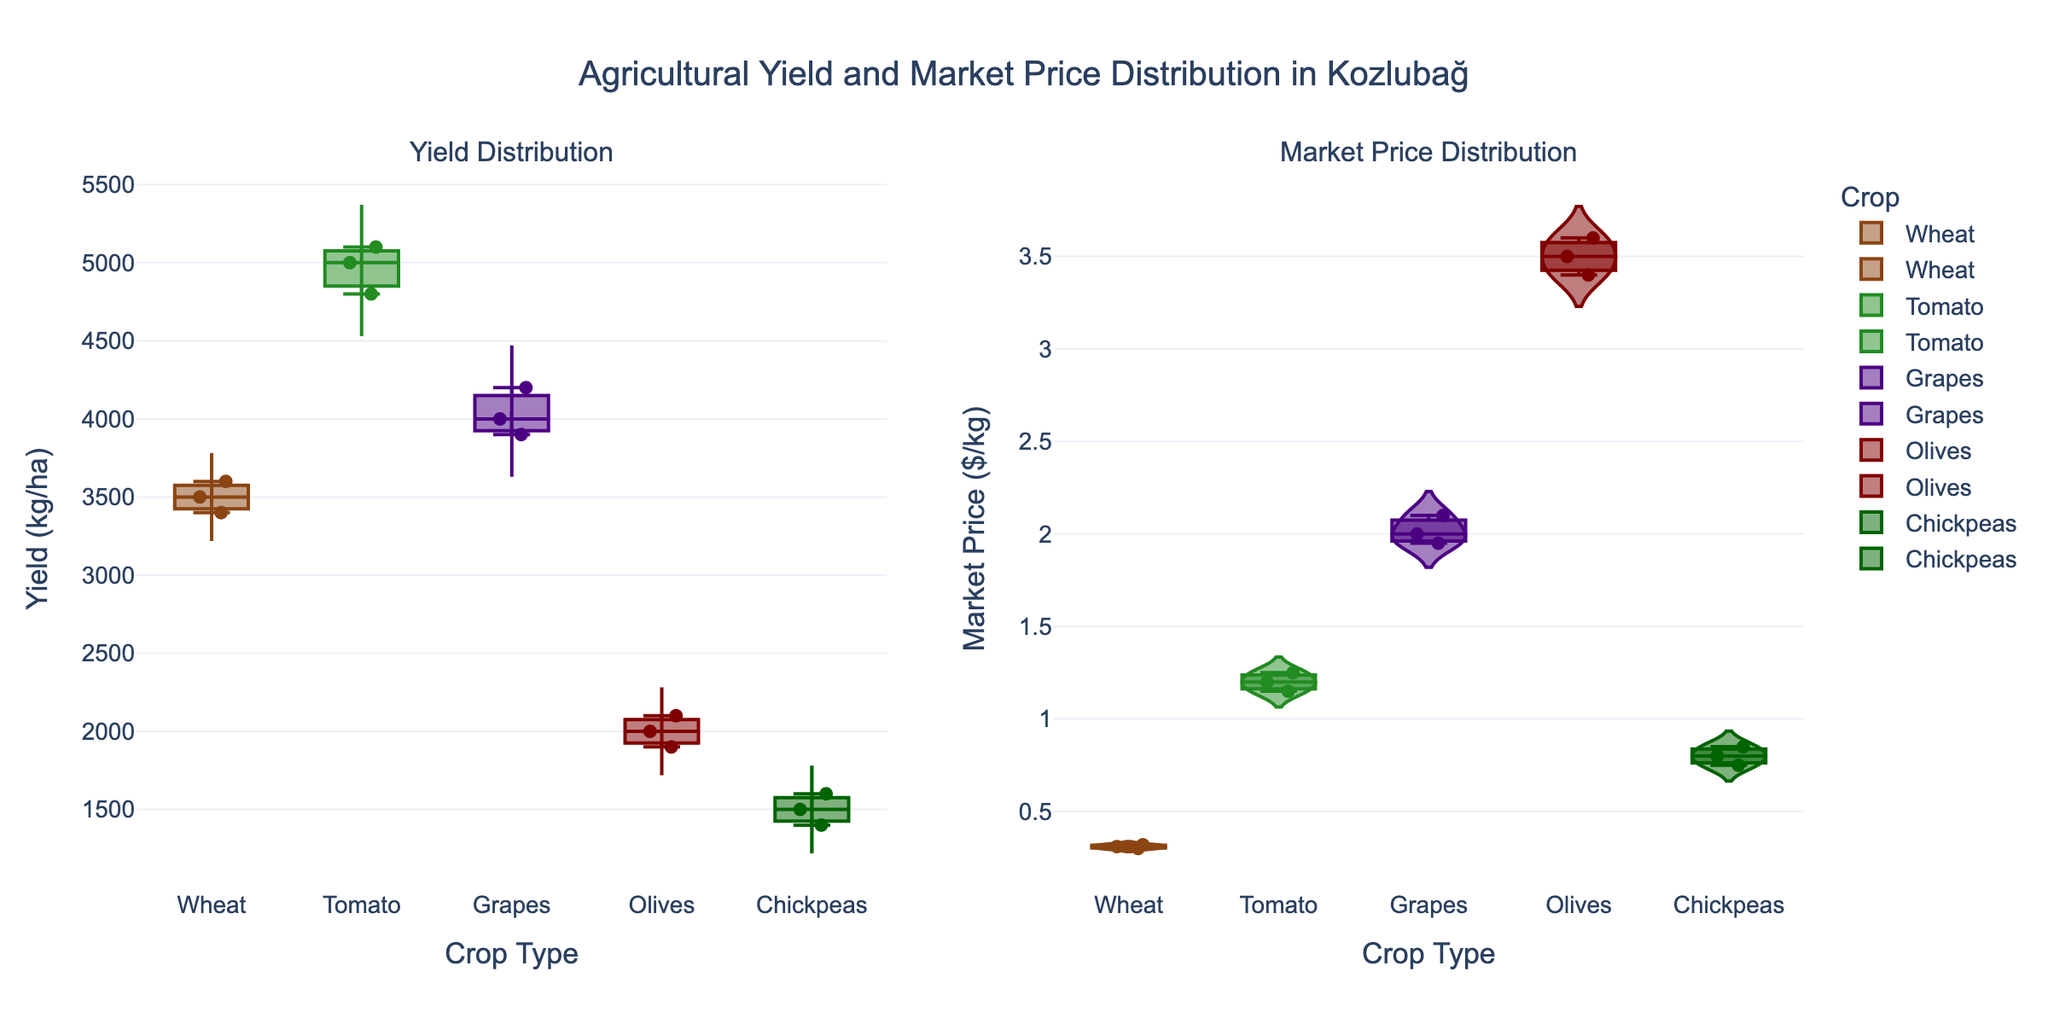Which crop has the highest median market price? The highest median market price can be determined by looking at the distribution in the second subplot for each crop. Olives have the highest range and thus the highest median value.
Answer: Olives Which crop shows the most variability in yield? Variability in yield can be gauged by looking at the spread of the violin plot in the first subplot for each crop. Grapes show the widest spread, indicating the most variability.
Answer: Grapes What's the median yield for Chickpeas? Look at the box plot for Chickpeas in the first subplot and find the center line inside the box, which represents the median.
Answer: 1500 kg/ha How do the market prices of Tomatoes compare to Olives? Compare the second subplot where both the distributions and individual data points are shown. Olives have significantly higher market prices than Tomatoes.
Answer: Olives have higher prices than Tomatoes What is the range of yields for Wheat? To determine the range, find the minimum and maximum values for Wheat in the first subplot. The minimum yield is 3400 kg/ha and the maximum is 3600 kg/ha. The range is the difference between them.
Answer: 200 kg/ha How does the median yield of Grapes compare to Tomatoes? Find the median values of Grapes and Tomatoes by looking at the middle line of their respective box plots in the first subplot. Grapes have a higher median yield compared to Tomatoes.
Answer: Grapes have a higher median yield Which crop has the lowest market price and what is it? To find the lowest market price, look at the minimum value in the second subplot for each crop. Chickpeas have the lowest market price, indicated by the shortest bar in the distribution.
Answer: Chickpeas, $0.75/kg Among Wheat, Tomatoes, and Chickpeas, which has the least variable market price? To determine variability, look at the spread of the violin plots in the second subplot. Wheat has the least spread, indicating the least variability.
Answer: Wheat Which crop has the narrowest interquartile range (IQR) for market prices? The IQR is represented by the box in the box plot, where the narrowest box indicates the smallest IQR. For market prices, Wheat appears to have the narrowest IQR in the second subplot.
Answer: Wheat What is the relationship between yield and market price for Olives? To understand the relationship, compare the distribution shapes and individual points for Olives in both subplots. Higher yield generally seems associated with higher market prices for Olives.
Answer: Higher yield generally correlates with higher market prices 